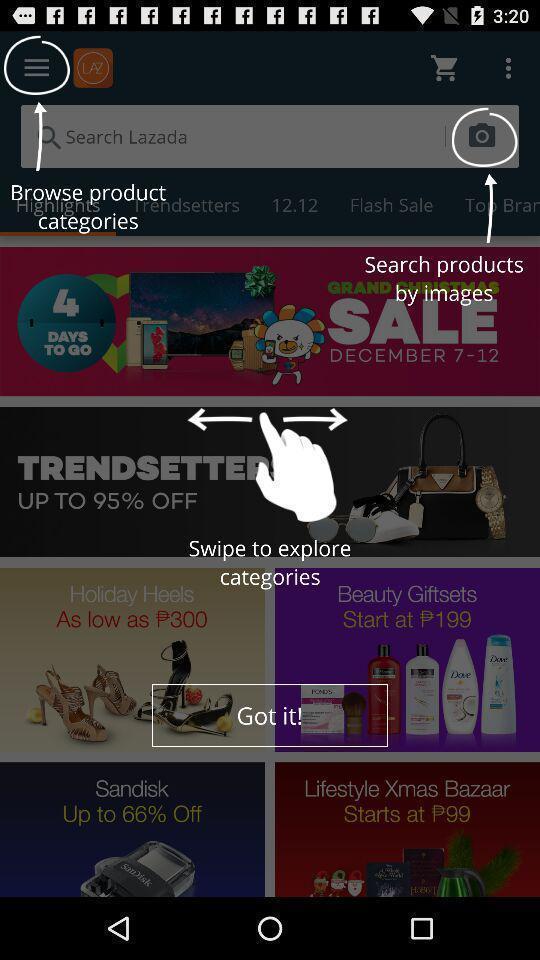Provide a description of this screenshot. Search page displaying various items in shopping app. 